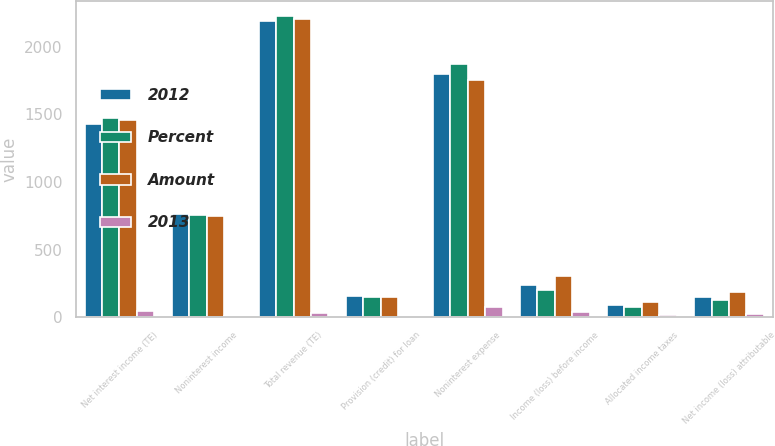Convert chart. <chart><loc_0><loc_0><loc_500><loc_500><stacked_bar_chart><ecel><fcel>Net interest income (TE)<fcel>Noninterest income<fcel>Total revenue (TE)<fcel>Provision (credit) for loan<fcel>Noninterest expense<fcel>Income (loss) before income<fcel>Allocated income taxes<fcel>Net income (loss) attributable<nl><fcel>2012<fcel>1425<fcel>766<fcel>2191<fcel>156<fcel>1794<fcel>241<fcel>90<fcel>151<nl><fcel>Percent<fcel>1472<fcel>753<fcel>2225<fcel>150<fcel>1870<fcel>205<fcel>76<fcel>129<nl><fcel>Amount<fcel>1456<fcel>750<fcel>2206<fcel>148<fcel>1754<fcel>304<fcel>113<fcel>191<nl><fcel>2013<fcel>47<fcel>13<fcel>34<fcel>6<fcel>76<fcel>36<fcel>14<fcel>22<nl></chart> 